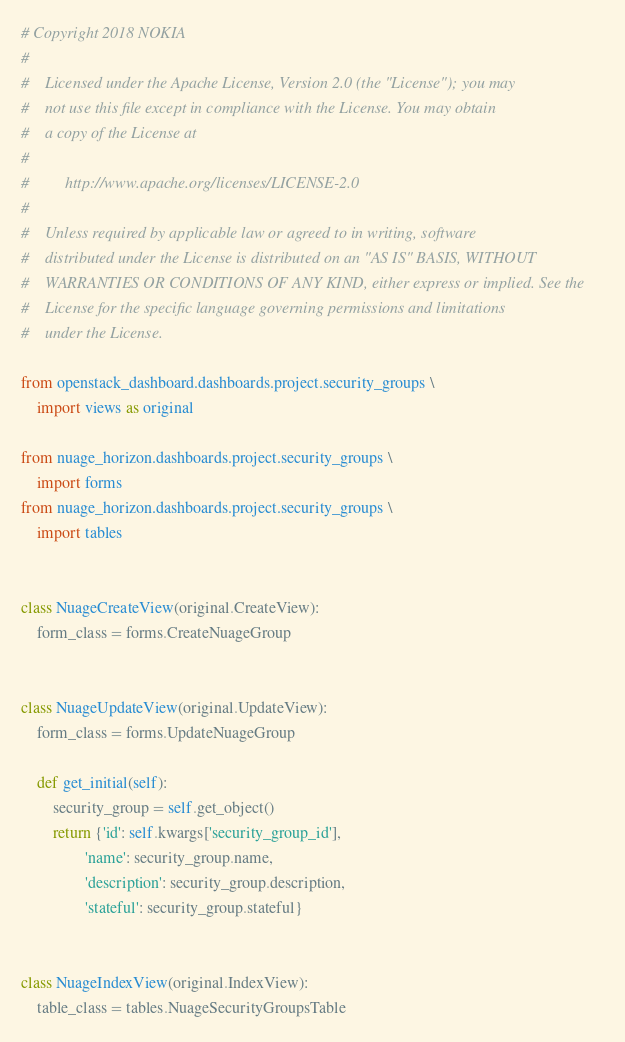Convert code to text. <code><loc_0><loc_0><loc_500><loc_500><_Python_># Copyright 2018 NOKIA
#
#    Licensed under the Apache License, Version 2.0 (the "License"); you may
#    not use this file except in compliance with the License. You may obtain
#    a copy of the License at
#
#         http://www.apache.org/licenses/LICENSE-2.0
#
#    Unless required by applicable law or agreed to in writing, software
#    distributed under the License is distributed on an "AS IS" BASIS, WITHOUT
#    WARRANTIES OR CONDITIONS OF ANY KIND, either express or implied. See the
#    License for the specific language governing permissions and limitations
#    under the License.

from openstack_dashboard.dashboards.project.security_groups \
    import views as original

from nuage_horizon.dashboards.project.security_groups \
    import forms
from nuage_horizon.dashboards.project.security_groups \
    import tables


class NuageCreateView(original.CreateView):
    form_class = forms.CreateNuageGroup


class NuageUpdateView(original.UpdateView):
    form_class = forms.UpdateNuageGroup

    def get_initial(self):
        security_group = self.get_object()
        return {'id': self.kwargs['security_group_id'],
                'name': security_group.name,
                'description': security_group.description,
                'stateful': security_group.stateful}


class NuageIndexView(original.IndexView):
    table_class = tables.NuageSecurityGroupsTable
</code> 